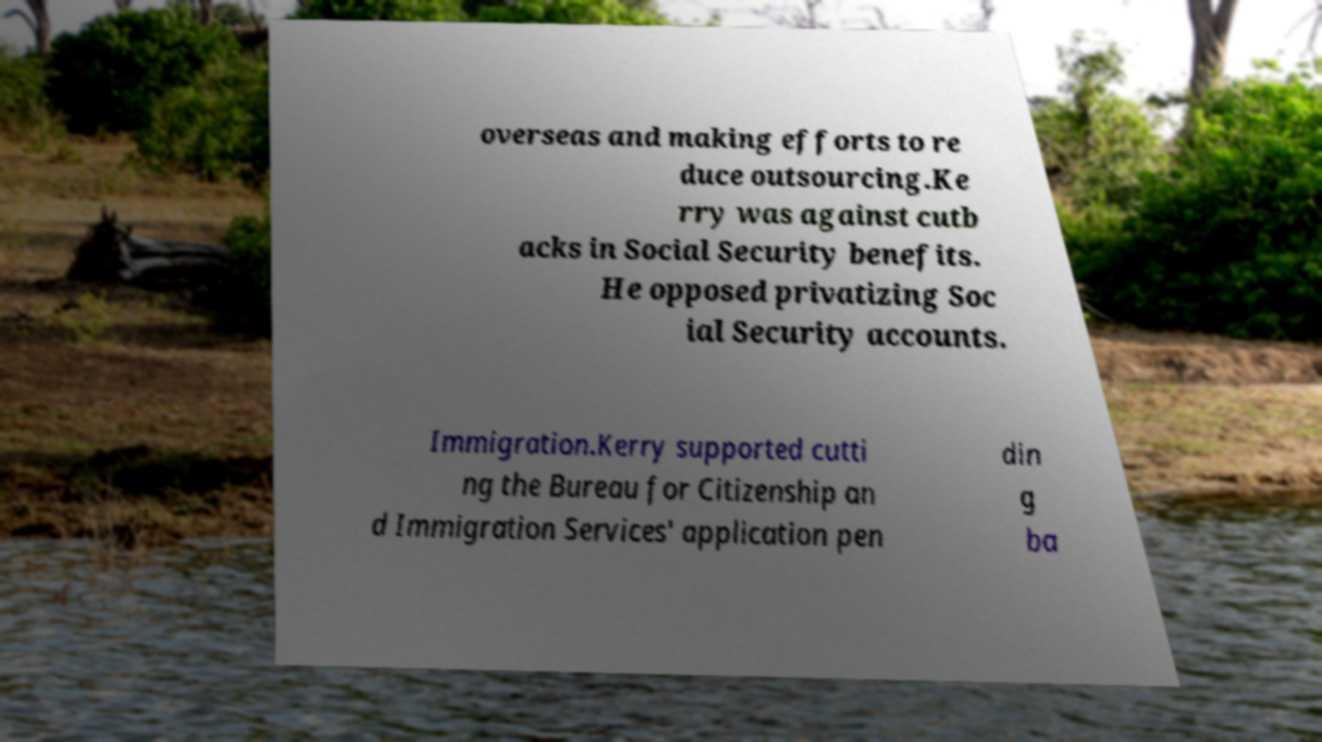What messages or text are displayed in this image? I need them in a readable, typed format. overseas and making efforts to re duce outsourcing.Ke rry was against cutb acks in Social Security benefits. He opposed privatizing Soc ial Security accounts. Immigration.Kerry supported cutti ng the Bureau for Citizenship an d Immigration Services' application pen din g ba 